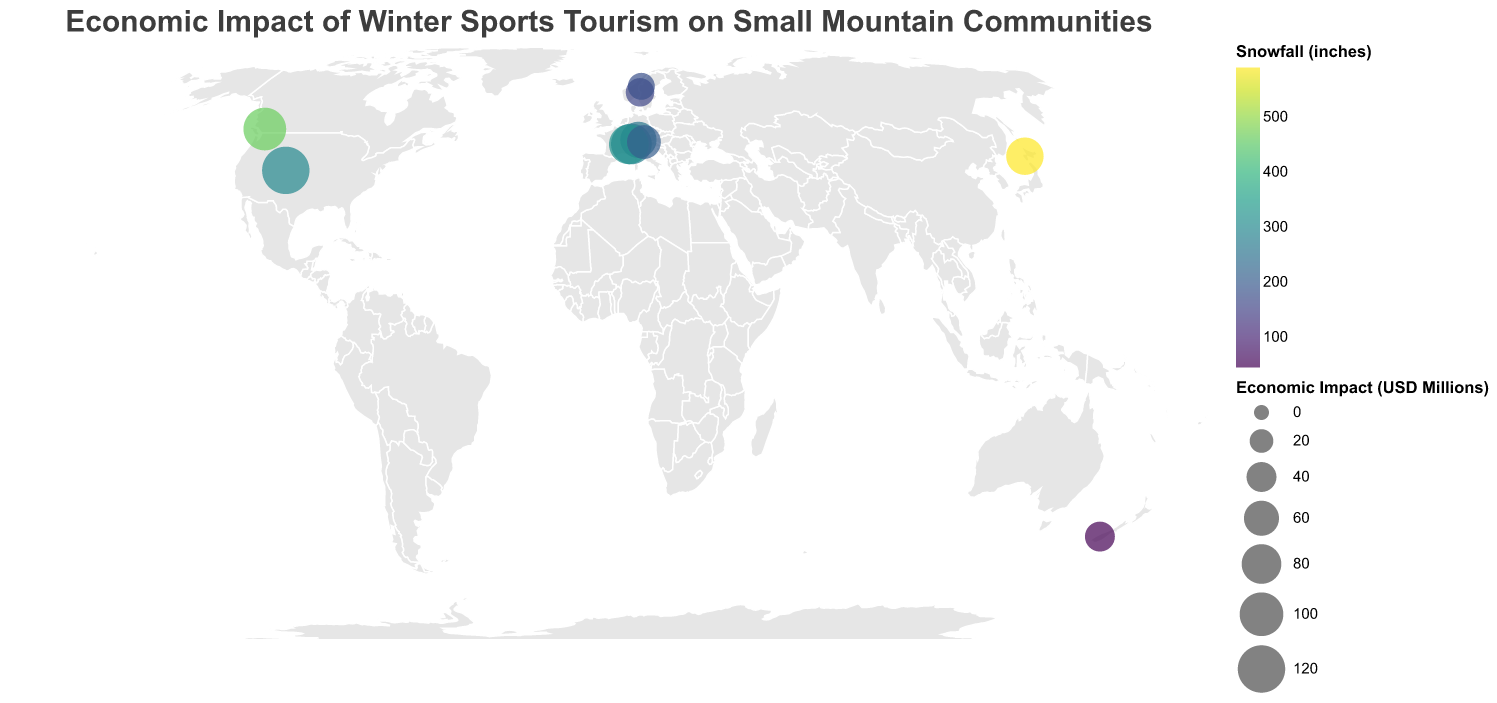What is the average economic impact of the towns shown on the map? To find the average economic impact, sum the economic impact of all towns (120 + 95 + 85 + 70 + 65 + 80 + 55 + 40 + 35 + 30 = 675) and divide by the number of towns (10). So, the average is 675/10 = 67.5.
Answer: 67.5 Which town has the highest economic impact and what is it? By looking at the size of the circles, Aspen in the USA has the largest circle, indicating the highest economic impact. The tooltip confirms it is 120 million USD.
Answer: Aspen, 120 million USD How much snowfall does Whistler get compared to Chamonix? Using the color scale and tooltips, Whistler has 465 inches and Chamonix has 320 inches.
Answer: Whistler: 465 inches, Chamonix: 320 inches Are there any towns with more than 5 ski resorts? Checking the tooltips, only Niseko in Japan has more than 5 ski resorts, with exactly 5 ski resorts.
Answer: Niseko Which town, indicated by the largest colored circle, is in Europe? By matching the larger circles in Europe to their countries, Zermatt in Switzerland has the largest colored circle in Europe, which indicates it has a significant economic impact and substantial snowfall.
Answer: Zermatt What is the range of average tourist stays among these towns? By examining the tooltips, the shortest stay is in Åre with 3.6 days, and the longest is in Niseko with 7.3 days. The range is 7.3 - 3.6 = 3.7 days.
Answer: 3.7 days Which town has the least snowfall and what is the amount? By using the color legend and checking the tooltips, Queenstown in New Zealand has the least snowfall with 45 inches.
Answer: Queenstown, 45 inches Is there a town with exactly 1 ski resort? If so, name it. Checking the tooltips, St. Anton in Austria and Trysil in Norway both have exactly 1 ski resort.
Answer: St. Anton and Trysil What is the total economic impact of all the European towns combined? Add the economic impacts of Zermatt (85), St. Anton (65), Chamonix (80), Cortina d'Ampezzo (55), Trysil (35), and Åre (30): 85 + 65 + 80 + 55 + 35 + 30 = 350 million USD.
Answer: 350 million USD Considering the economic impact, which town ranks second in economic contribution after Aspen? From the tooltips, Whistler in Canada has the second highest economic impact at 95 million USD.
Answer: Whistler, 95 million USD 